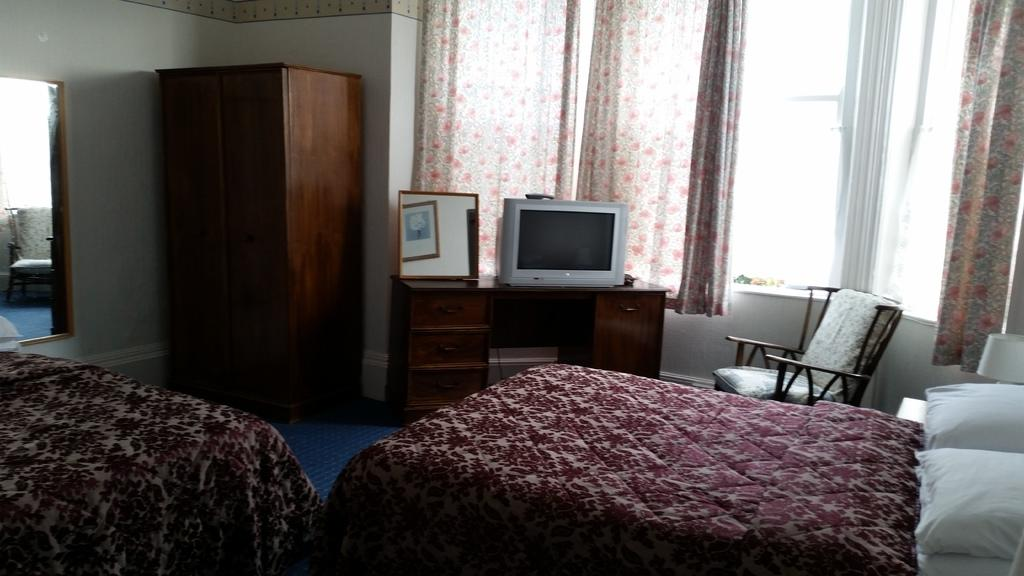How many beds are present in the image? There are two beds in the image. What other furniture can be seen in the image? There is a chair, a TV, a shelf, and a cupboard in the image. Is there any source of natural light in the image? Yes, there is a window in the image. What type of window treatment is present in the image? There are curtains associated with the window. What type of death can be seen in the image? There is no death present in the image; it features furniture and a window with curtains. What type of crush is visible in the image? There is no crush present in the image; it features furniture and a window with curtains. 